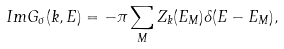Convert formula to latex. <formula><loc_0><loc_0><loc_500><loc_500>I m G _ { \sigma } ( k , E ) = - \pi \sum _ { M } Z _ { k } ( E _ { M } ) \delta ( E - E _ { M } ) ,</formula> 